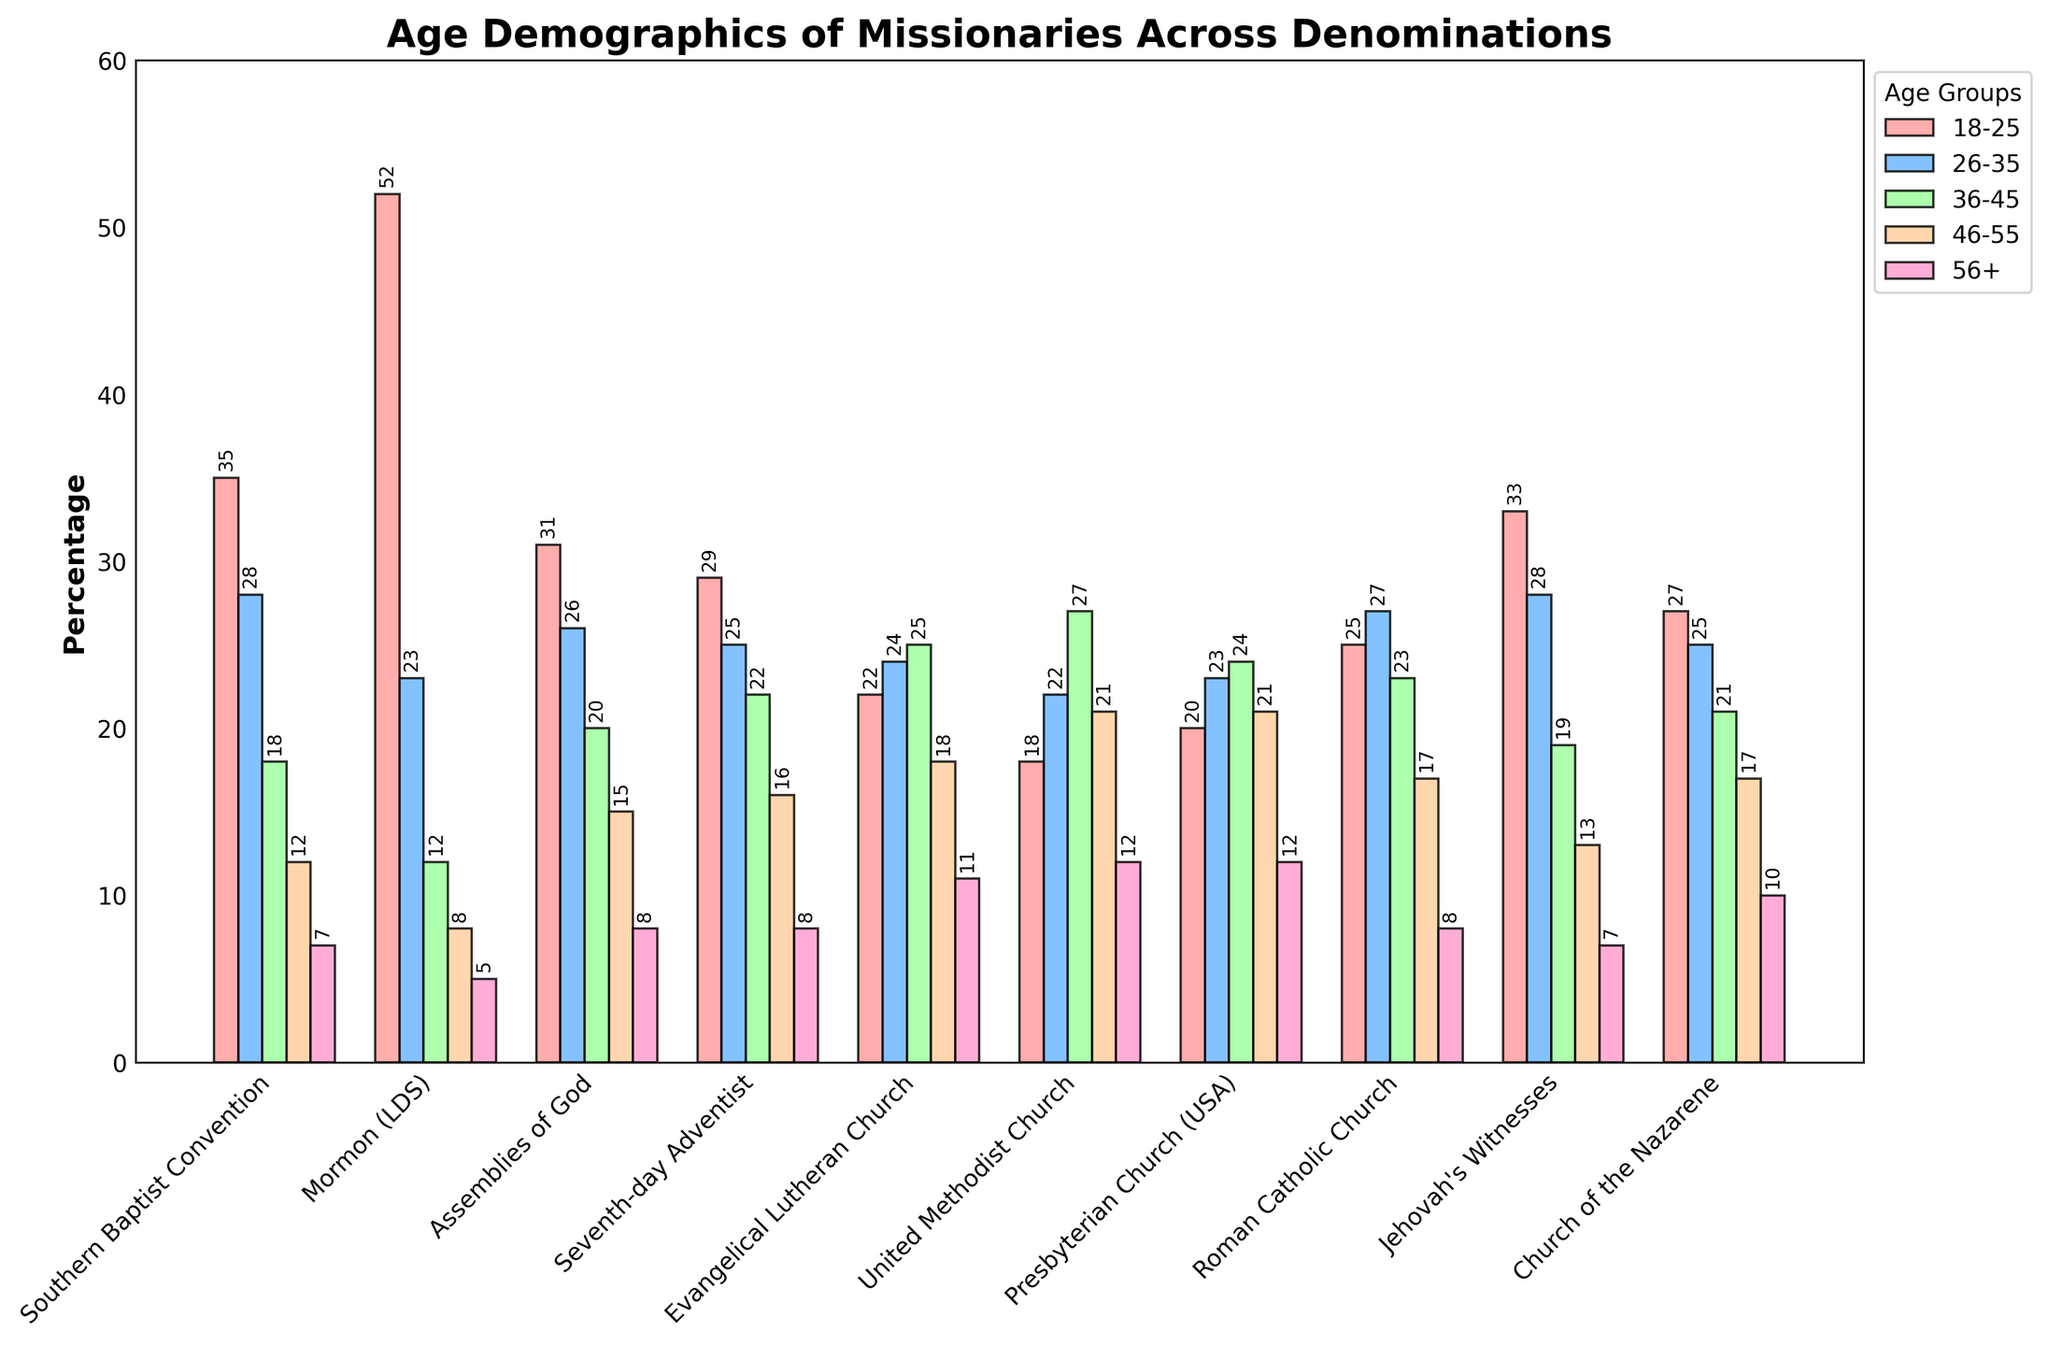Which denomination has the highest percentage of missionaries aged 18-25? Look at the heights of the bars for the age group 18-25 across all denominations. The bar for the Mormon (LDS) denomination is the tallest.
Answer: Mormon (LDS) Which denomination has more missionaries aged 56+ than aged 18-25? Compare the bars for ages 18-25 and 56+ for each denomination. None of the denominations have a higher percentage for 56+ than 18-25.
Answer: None Which age group is most balanced across denominations? Inspect the bars' relative heights across denominations for each age group. The 26-35 group has relatively similar heights in many denominations.
Answer: 26-35 What's the total percentage of missionaries aged 18-45 in the Roman Catholic Church? Sum the percentages for ages 18-25, 26-35, and 36-45 for the Roman Catholic Church: 25 + 27 + 23
Answer: 75% In which denomination do the missionaries aged 46-55 make up the largest percentage? Look at the heights of the bars for the age group 46-55 across all denominations. The United Methodist Church and the Presbyterian Church (USA) both have the tallest bars for this group.
Answer: United Methodist Church and Presbyterian Church (USA) Which age group in the Southern Baptist Convention has the smallest percentage? Compare the heights of the bars for each age group within the Southern Baptist Convention. The age group 56+ has the smallest bar.
Answer: 56+ Does the Assemblies of God denomination have more missionaries aged 26-35 or 36-45? Compare the heights of the bars for ages 26-35 and 36-45 within the Assemblies of God denomination. The bar for ages 26-35 is slightly taller.
Answer: 26-35 Which denomination has a higher percentage of missionaries aged 26-35 than aged 18-25? Compare the heights of the bars for ages 26-35 and 18-25 for each denomination. The Evangelical Lutheran Church, United Methodist Church, and Presbyterian Church (USA) have taller bars for 26-35.
Answer: Evangelical Lutheran Church, United Methodist Church, Presbyterian Church (USA) What percentage of Seventh-day Adventist missionaries are aged 46-55 or older? Add the percentages for ages 46-55 and 56+ within the Seventh-day Adventist denomination: 16 + 8
Answer: 24% Which denomination has the highest percentage of missionaries aged 36-45? Compare the heights of the bars for the age group 36-45 across all denominations. The Evangelical Lutheran Church has the tallest bar for this group.
Answer: Evangelical Lutheran Church 